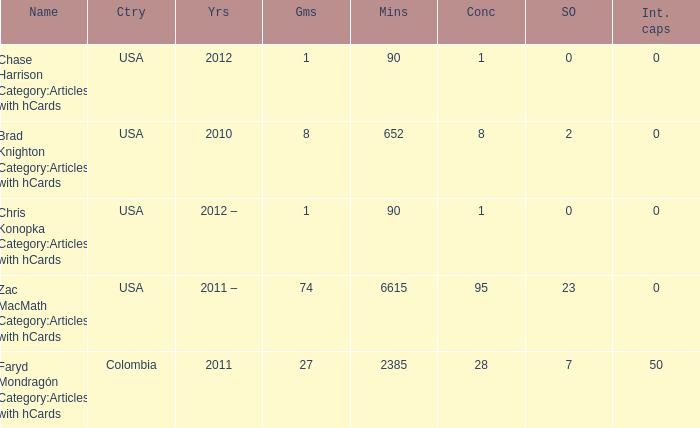When chase harrison category:articles with hcards is the name what is the year? 2012.0. 